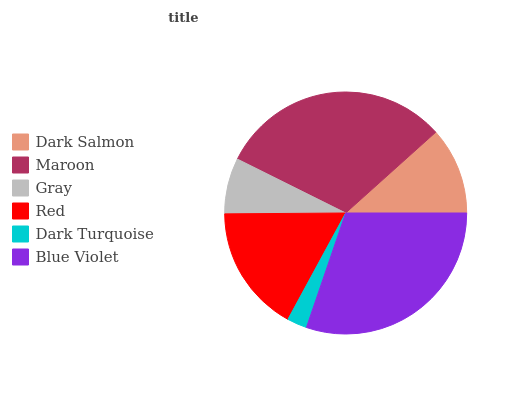Is Dark Turquoise the minimum?
Answer yes or no. Yes. Is Maroon the maximum?
Answer yes or no. Yes. Is Gray the minimum?
Answer yes or no. No. Is Gray the maximum?
Answer yes or no. No. Is Maroon greater than Gray?
Answer yes or no. Yes. Is Gray less than Maroon?
Answer yes or no. Yes. Is Gray greater than Maroon?
Answer yes or no. No. Is Maroon less than Gray?
Answer yes or no. No. Is Red the high median?
Answer yes or no. Yes. Is Dark Salmon the low median?
Answer yes or no. Yes. Is Gray the high median?
Answer yes or no. No. Is Red the low median?
Answer yes or no. No. 